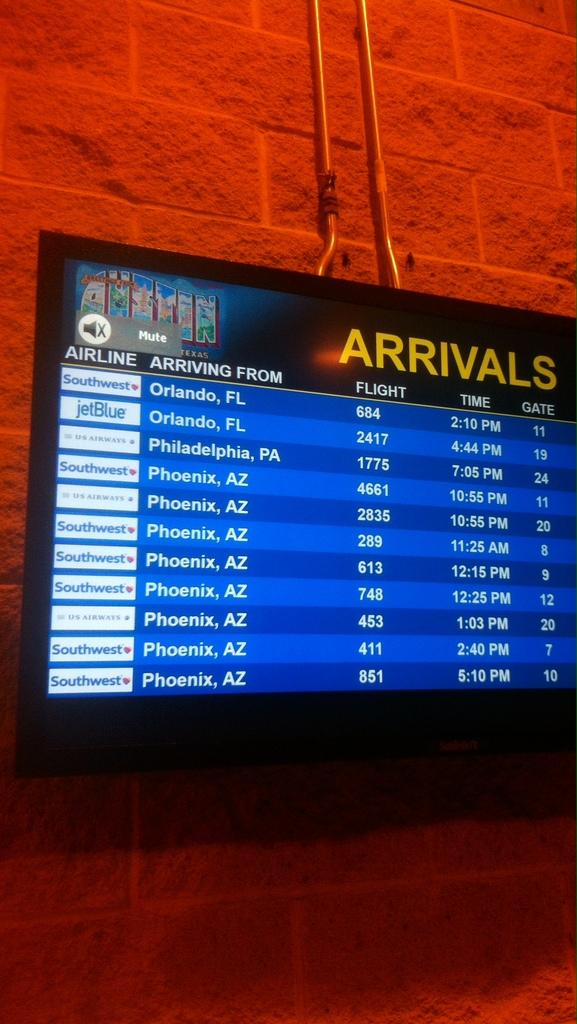What is on the wall in the image? There is a screen on the wall. Are there any other objects or features on the wall besides the screen? Yes, there are other things on the wall. How many ladybugs can be seen crawling on the screen in the image? There are no ladybugs present in the image. What emotion might the person in the image be feeling based on the presence of a ladybug? There is no person or emotion mentioned in the image, and there are no ladybugs present. 